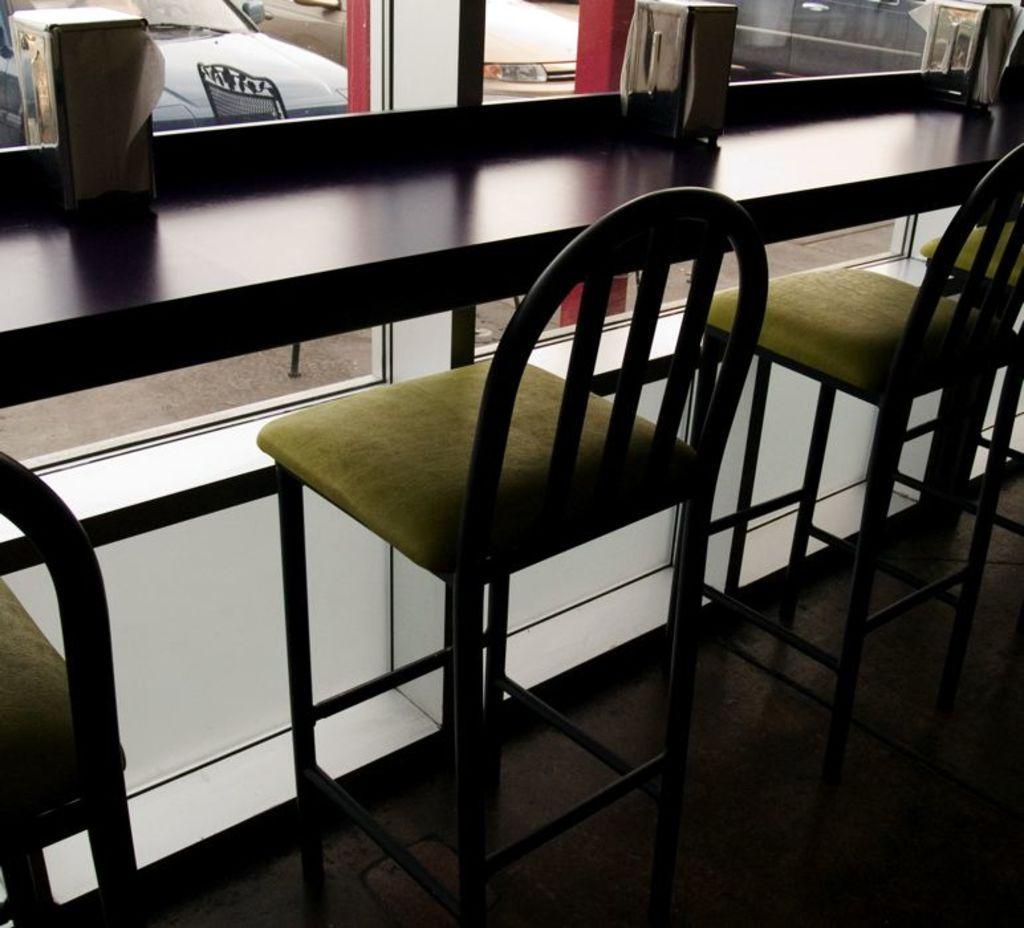Could you give a brief overview of what you see in this image? In this image there are chairs. In front of the chairs there is a wooden table. On top of it there are few objects. There are glass windows through which we can see cars. At the bottom of the image there is a floor. 